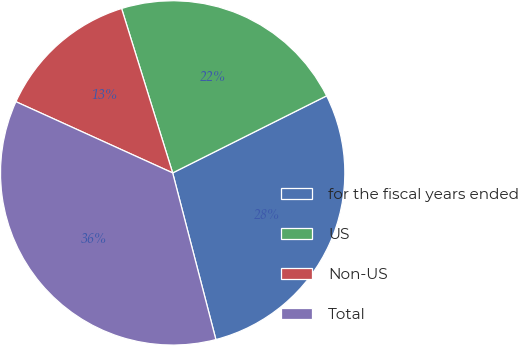<chart> <loc_0><loc_0><loc_500><loc_500><pie_chart><fcel>for the fiscal years ended<fcel>US<fcel>Non-US<fcel>Total<nl><fcel>28.35%<fcel>22.41%<fcel>13.42%<fcel>35.83%<nl></chart> 